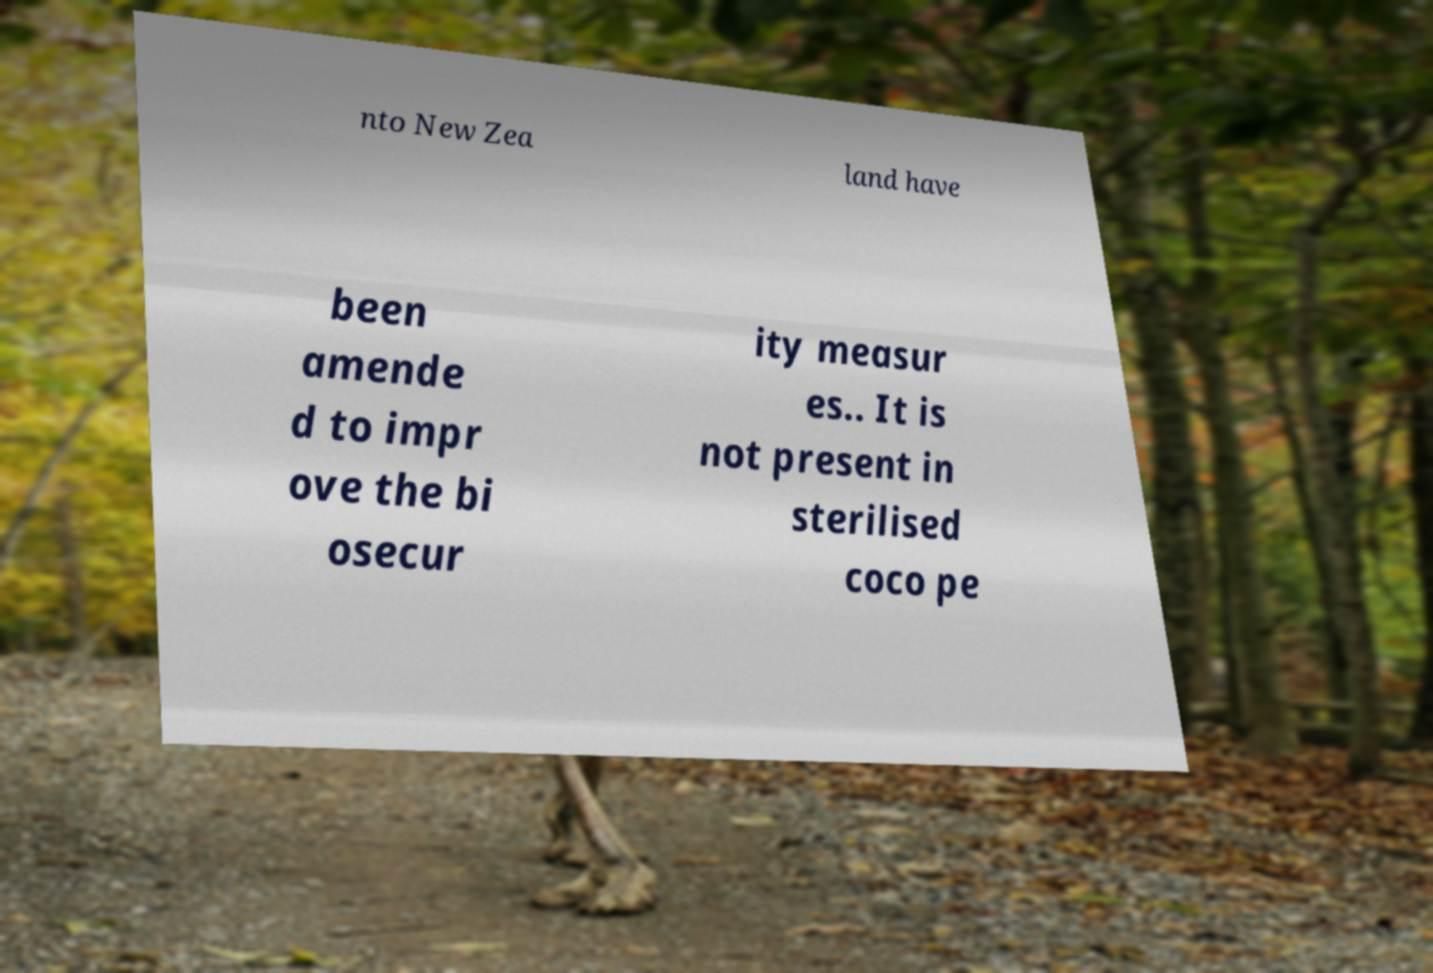Can you read and provide the text displayed in the image?This photo seems to have some interesting text. Can you extract and type it out for me? nto New Zea land have been amende d to impr ove the bi osecur ity measur es.. It is not present in sterilised coco pe 